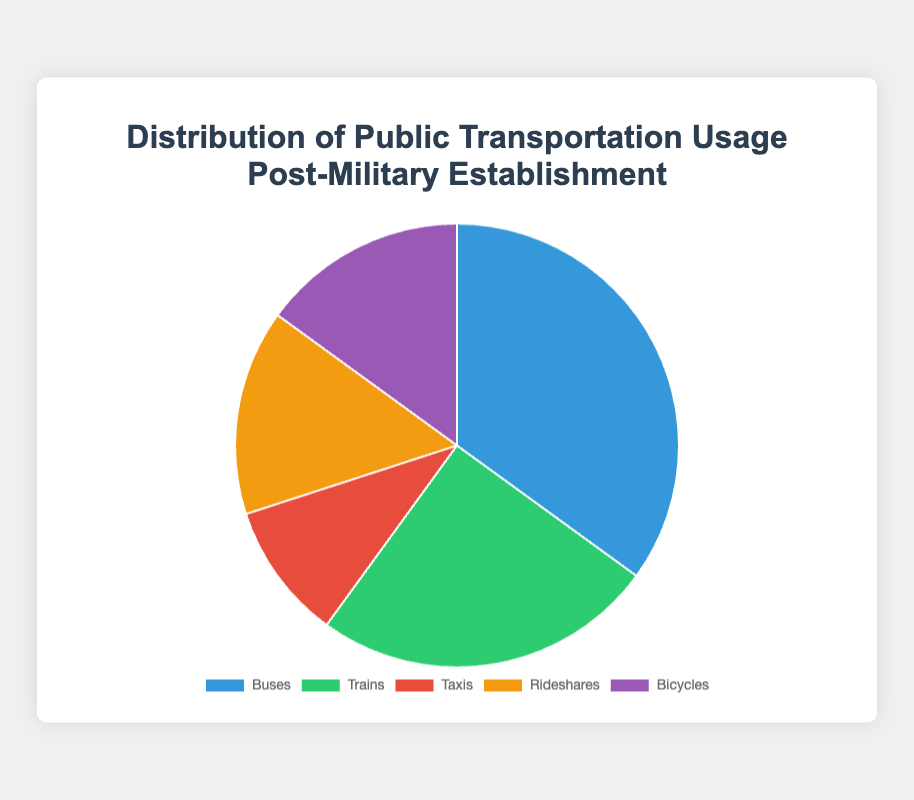What is the mode of transportation with the highest usage? The figure shows different transportation modes with their respective usage percentages. The mode with the largest percentage segment has 35%, which corresponds to Buses.
Answer: Buses Which transportation modes have equal usage percentages? From the pie chart, Rideshares and Bicycles both have segments that are the same size, each accounting for 15% usage.
Answer: Rideshares and Bicycles What is the combined usage percentage of Buses and Trains? The usage percentages for Buses and Trains are 35% and 25% respectively. Adding these two amounts: 35% + 25% = 60%.
Answer: 60% Which transportation mode has a higher usage: Taxis or Rideshares? The figure shows that Taxis have 10% usage while Rideshares have a higher usage of 15%.
Answer: Rideshares What is the difference in usage between the most and least used transportation modes? The most used mode is Buses at 35%, and the least used is Taxis at 10%. The difference is calculated as 35% - 10% = 25%.
Answer: 25% What is the average usage percentage of all the transportation modes? To find the average, sum up all the usage percentages: 35% (Buses) + 25% (Trains) + 10% (Taxis) + 15% (Rideshares) + 15% (Bicycles) = 100%. Divide this sum by the number of modes (5): 100% / 5 = 20%.
Answer: 20% Based on color representation, which mode of transportation is represented by green? Observing the color legend in the pie chart, we see that green corresponds to Trains.
Answer: Trains What percentage of the total transportation usage is accounted for by non-bus transportation modes? To find this, subtract the usage percentage of Buses from 100%: 100% - 35% = 65%.
Answer: 65% How does the usage of Rideshares compare to the usage of Taxis? The pie chart shows that Rideshares have 15% usage, whereas Taxis have 10% usage. Rideshares have a 5% greater usage than Taxis.
Answer: 5% What is the cumulative percentage for the least two used modes? The least two used modes are Taxis (10%) and Rideshares or Bicycles (each 15%). Their combined usage is 10% + 15% = 25%.
Answer: 25% 